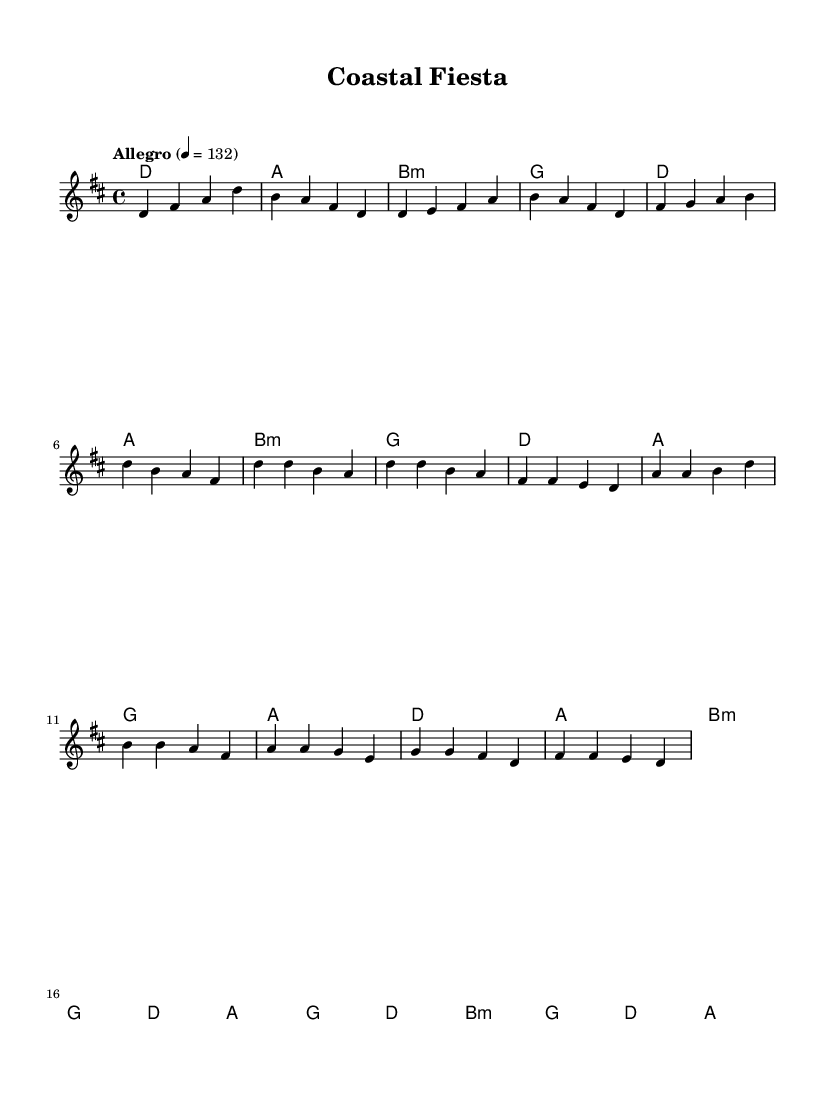What is the key signature of this music? The key signature shows two sharps (F# and C#), indicating that the music is in D major.
Answer: D major What is the time signature of this score? The time signature is indicated as 4/4, meaning there are four beats per measure and a quarter note gets one beat.
Answer: 4/4 What is the tempo marking indicated in this piece? The tempo marking states "Allegro" with a metronome marking of 132 beats per minute, indicating a fast and lively pace.
Answer: Allegro, 132 How many measures are in the chorus section? By examining the structure of the sheet music, the chorus contains four measures.
Answer: 4 Which section of the music features the chord progression D, A, B minor, G? Observing the harmony section, this chord progression occurs in both the intro and verse sections.
Answer: Intro and verse What musical element indicates the upbeat nature of this piece? The use of an "Allegro" tempo combined with the upbeat chord progressions and melodic arcs contributes to the lively character typical of Mediterranean-inspired music.
Answer: Allegro How does the bridge section differ harmonically from the verse? The bridge introduces a B minor chord at the beginning and resolves differently compared to the verse, which predominantly stays within D major. This shift creates contrast in the structure.
Answer: B minor 